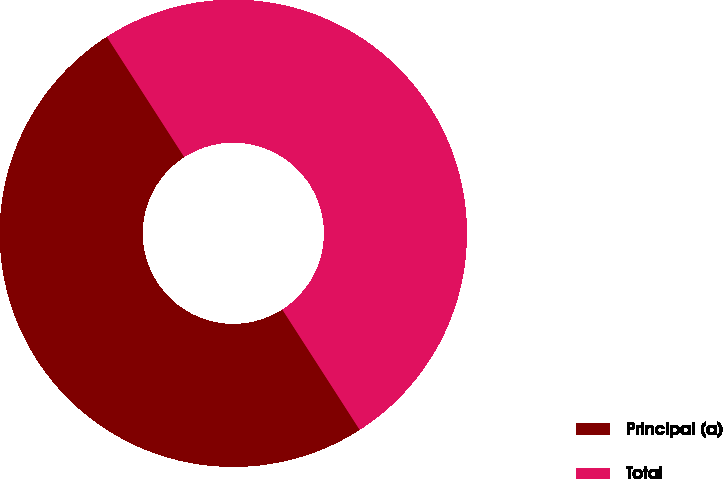Convert chart. <chart><loc_0><loc_0><loc_500><loc_500><pie_chart><fcel>Principal (a)<fcel>Total<nl><fcel>50.0%<fcel>50.0%<nl></chart> 